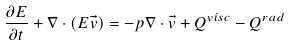<formula> <loc_0><loc_0><loc_500><loc_500>\frac { \partial E } { \partial t } + \nabla \cdot ( E \vec { v } ) = - p \nabla \cdot \vec { v } + Q ^ { v i s c } - Q ^ { r a d }</formula> 